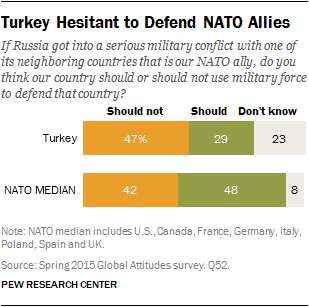Mention a couple of crucial points in this snapshot. There is a significant gap in the median level of knowledge among NATO members and Turkey regarding the difference between Turkey and NATO. In Turkey, 23% of people do not know the answer to the question. 